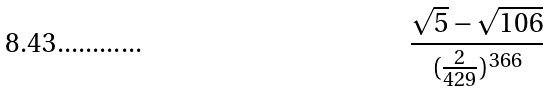<formula> <loc_0><loc_0><loc_500><loc_500>\frac { \sqrt { 5 } - \sqrt { 1 0 6 } } { ( \frac { 2 } { 4 2 9 } ) ^ { 3 6 6 } }</formula> 